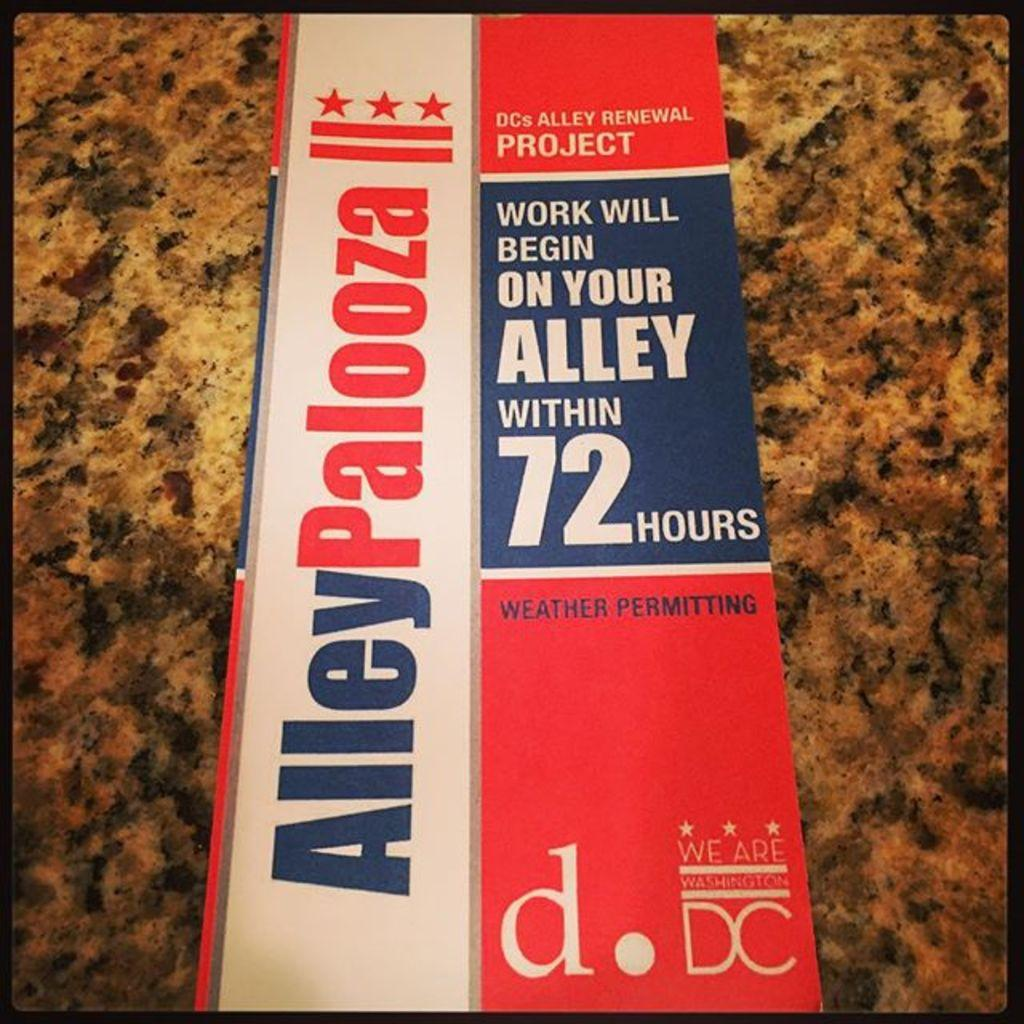<image>
Write a terse but informative summary of the picture. neighbors were sent this red white and blue flyer and road work in there area 